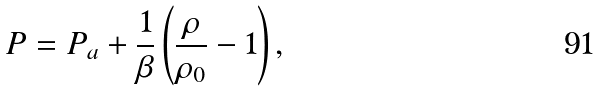<formula> <loc_0><loc_0><loc_500><loc_500>P = P _ { a } + \frac { 1 } { \beta } \left ( { \frac { \rho } { \rho _ { 0 } } - 1 } \right ) ,</formula> 